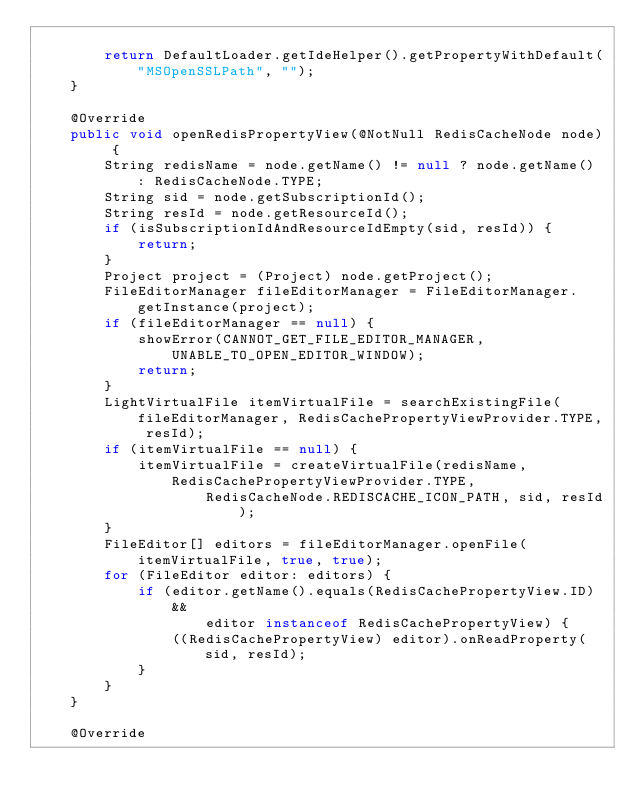Convert code to text. <code><loc_0><loc_0><loc_500><loc_500><_Java_>
        return DefaultLoader.getIdeHelper().getPropertyWithDefault("MSOpenSSLPath", "");
    }

    @Override
    public void openRedisPropertyView(@NotNull RedisCacheNode node) {
        String redisName = node.getName() != null ? node.getName() : RedisCacheNode.TYPE;
        String sid = node.getSubscriptionId();
        String resId = node.getResourceId();
        if (isSubscriptionIdAndResourceIdEmpty(sid, resId)) {
            return;
        }
        Project project = (Project) node.getProject();
        FileEditorManager fileEditorManager = FileEditorManager.getInstance(project);
        if (fileEditorManager == null) {
            showError(CANNOT_GET_FILE_EDITOR_MANAGER, UNABLE_TO_OPEN_EDITOR_WINDOW);
            return;
        }
        LightVirtualFile itemVirtualFile = searchExistingFile(fileEditorManager, RedisCachePropertyViewProvider.TYPE, resId);
        if (itemVirtualFile == null) {
            itemVirtualFile = createVirtualFile(redisName, RedisCachePropertyViewProvider.TYPE,
                    RedisCacheNode.REDISCACHE_ICON_PATH, sid, resId);
        }
        FileEditor[] editors = fileEditorManager.openFile(itemVirtualFile, true, true);
        for (FileEditor editor: editors) {
            if (editor.getName().equals(RedisCachePropertyView.ID) &&
                    editor instanceof RedisCachePropertyView) {
                ((RedisCachePropertyView) editor).onReadProperty(sid, resId);
            }
        }
    }

    @Override</code> 